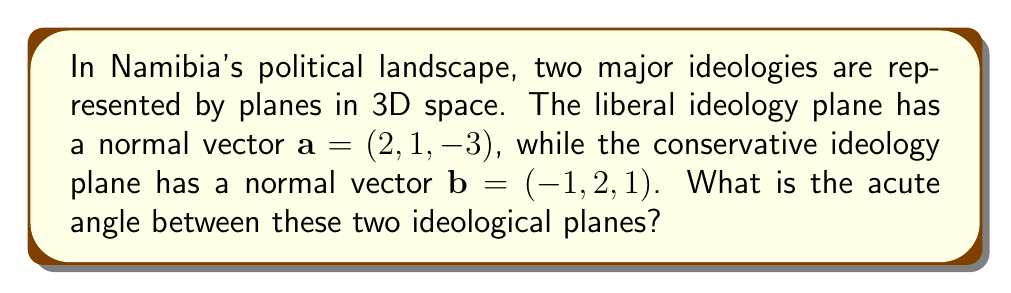Teach me how to tackle this problem. To find the angle between two planes, we need to calculate the angle between their normal vectors. We can use the dot product formula:

$$\cos \theta = \frac{\mathbf{a} \cdot \mathbf{b}}{|\mathbf{a}||\mathbf{b}|}$$

Step 1: Calculate the dot product $\mathbf{a} \cdot \mathbf{b}$
$$\mathbf{a} \cdot \mathbf{b} = (2)(-1) + (1)(2) + (-3)(1) = -2 + 2 - 3 = -3$$

Step 2: Calculate the magnitudes of vectors $\mathbf{a}$ and $\mathbf{b}$
$$|\mathbf{a}| = \sqrt{2^2 + 1^2 + (-3)^2} = \sqrt{4 + 1 + 9} = \sqrt{14}$$
$$|\mathbf{b}| = \sqrt{(-1)^2 + 2^2 + 1^2} = \sqrt{1 + 4 + 1} = \sqrt{6}$$

Step 3: Apply the dot product formula
$$\cos \theta = \frac{-3}{\sqrt{14}\sqrt{6}}$$

Step 4: Take the inverse cosine (arccos) of both sides
$$\theta = \arccos\left(\frac{-3}{\sqrt{14}\sqrt{6}}\right)$$

Step 5: Calculate the result (in radians)
$$\theta \approx 2.0344 \text{ radians}$$

Step 6: Convert to degrees
$$\theta \approx 116.57°$$

Since we want the acute angle, we subtract this result from 180°:
$$\text{Acute angle} = 180° - 116.57° = 63.43°$$
Answer: $63.43°$ 